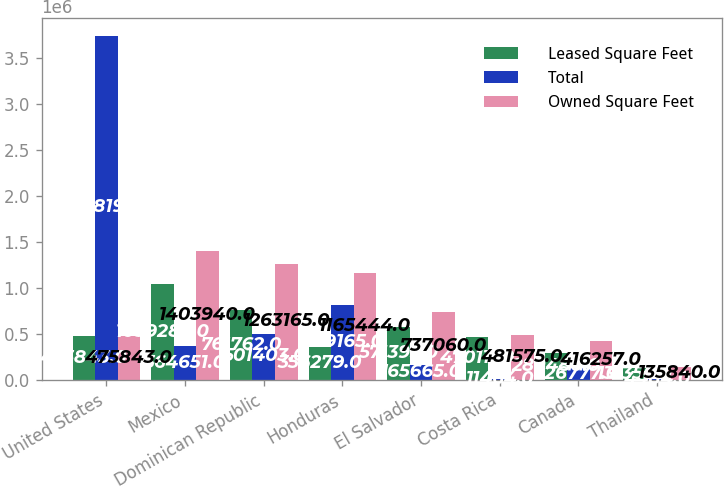Convert chart. <chart><loc_0><loc_0><loc_500><loc_500><stacked_bar_chart><ecel><fcel>United States<fcel>Mexico<fcel>Dominican Republic<fcel>Honduras<fcel>El Salvador<fcel>Costa Rica<fcel>Canada<fcel>Thailand<nl><fcel>Leased Square Feet<fcel>475843<fcel>1.03929e+06<fcel>761762<fcel>356279<fcel>571395<fcel>470111<fcel>289480<fcel>131356<nl><fcel>Total<fcel>3.73819e+06<fcel>364651<fcel>501403<fcel>809165<fcel>165665<fcel>11464<fcel>126777<fcel>4484<nl><fcel>Owned Square Feet<fcel>475843<fcel>1.40394e+06<fcel>1.26316e+06<fcel>1.16544e+06<fcel>737060<fcel>481575<fcel>416257<fcel>135840<nl></chart> 